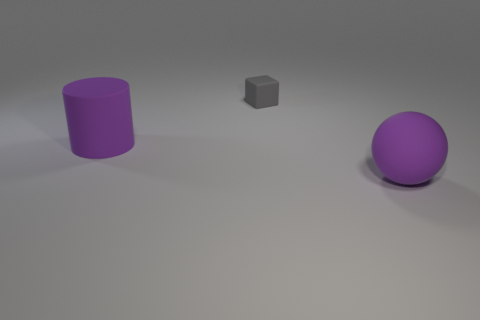Subtract all cubes. How many objects are left? 2 Add 1 red cylinders. How many objects exist? 4 Subtract 0 yellow cylinders. How many objects are left? 3 Subtract 1 cubes. How many cubes are left? 0 Subtract all purple spheres. How many green cubes are left? 0 Subtract all purple rubber spheres. Subtract all big purple rubber things. How many objects are left? 0 Add 1 large balls. How many large balls are left? 2 Add 3 purple shiny balls. How many purple shiny balls exist? 3 